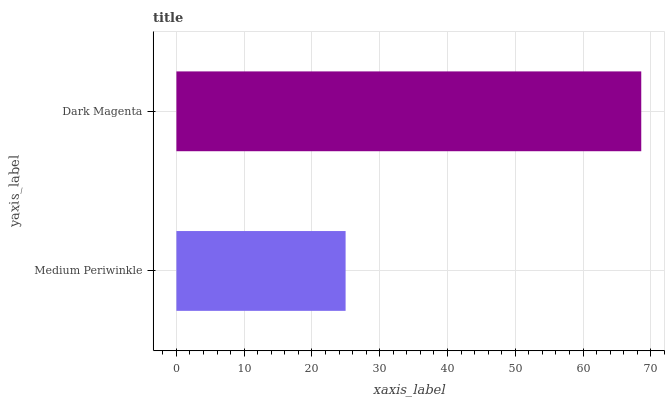Is Medium Periwinkle the minimum?
Answer yes or no. Yes. Is Dark Magenta the maximum?
Answer yes or no. Yes. Is Dark Magenta the minimum?
Answer yes or no. No. Is Dark Magenta greater than Medium Periwinkle?
Answer yes or no. Yes. Is Medium Periwinkle less than Dark Magenta?
Answer yes or no. Yes. Is Medium Periwinkle greater than Dark Magenta?
Answer yes or no. No. Is Dark Magenta less than Medium Periwinkle?
Answer yes or no. No. Is Dark Magenta the high median?
Answer yes or no. Yes. Is Medium Periwinkle the low median?
Answer yes or no. Yes. Is Medium Periwinkle the high median?
Answer yes or no. No. Is Dark Magenta the low median?
Answer yes or no. No. 